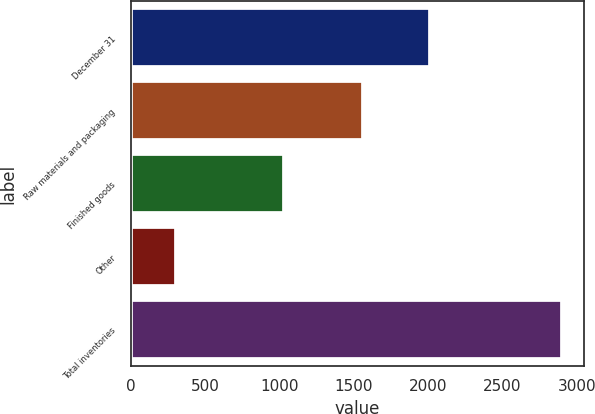Convert chart to OTSL. <chart><loc_0><loc_0><loc_500><loc_500><bar_chart><fcel>December 31<fcel>Raw materials and packaging<fcel>Finished goods<fcel>Other<fcel>Total inventories<nl><fcel>2015<fcel>1564<fcel>1032<fcel>306<fcel>2902<nl></chart> 